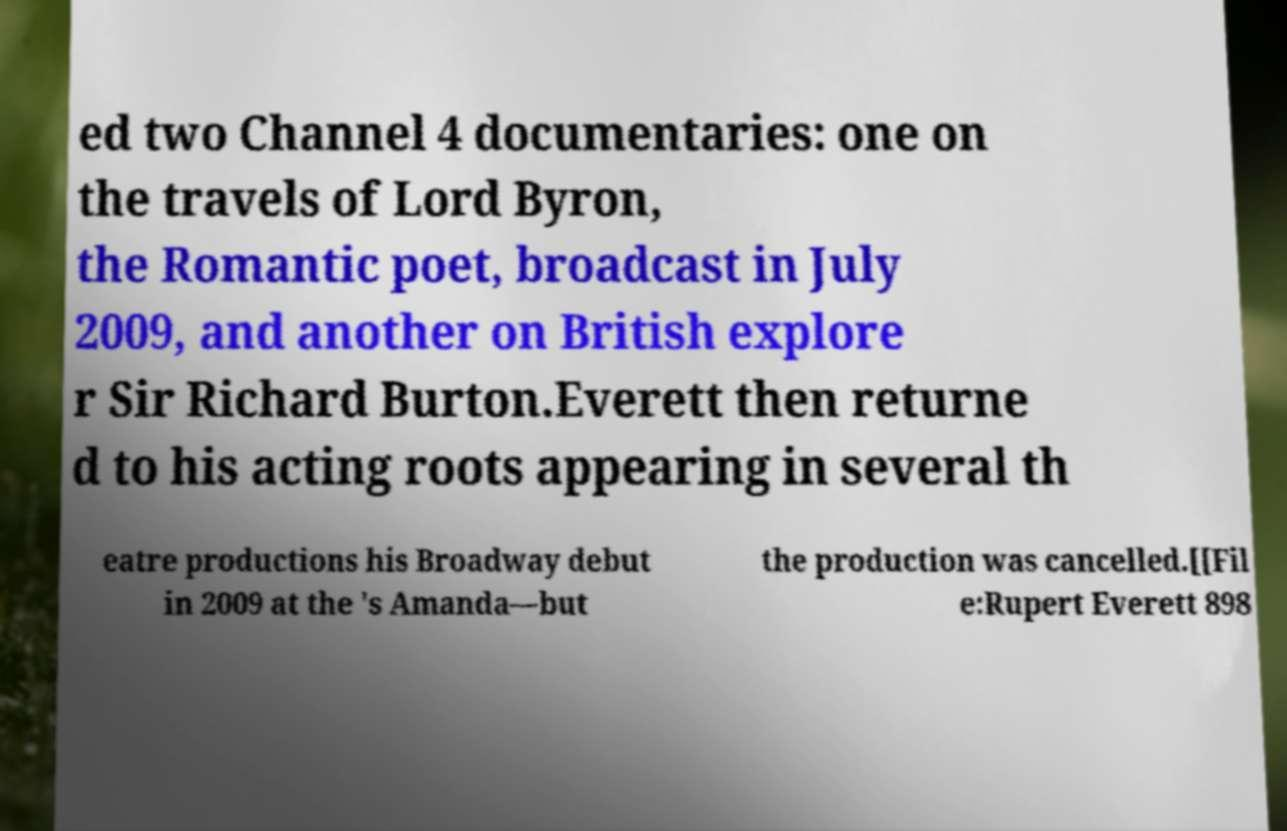Can you accurately transcribe the text from the provided image for me? ed two Channel 4 documentaries: one on the travels of Lord Byron, the Romantic poet, broadcast in July 2009, and another on British explore r Sir Richard Burton.Everett then returne d to his acting roots appearing in several th eatre productions his Broadway debut in 2009 at the 's Amanda—but the production was cancelled.[[Fil e:Rupert Everett 898 